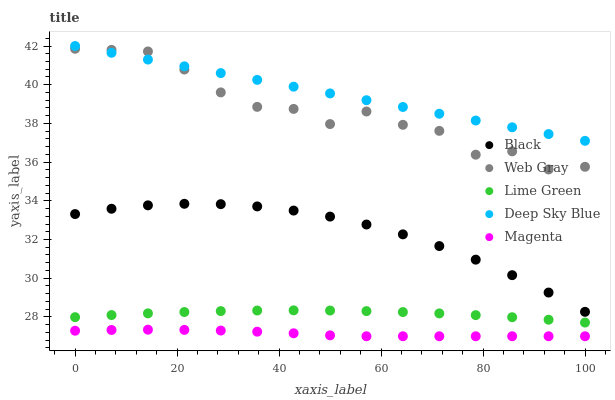Does Magenta have the minimum area under the curve?
Answer yes or no. Yes. Does Deep Sky Blue have the maximum area under the curve?
Answer yes or no. Yes. Does Web Gray have the minimum area under the curve?
Answer yes or no. No. Does Web Gray have the maximum area under the curve?
Answer yes or no. No. Is Deep Sky Blue the smoothest?
Answer yes or no. Yes. Is Web Gray the roughest?
Answer yes or no. Yes. Is Magenta the smoothest?
Answer yes or no. No. Is Magenta the roughest?
Answer yes or no. No. Does Magenta have the lowest value?
Answer yes or no. Yes. Does Web Gray have the lowest value?
Answer yes or no. No. Does Deep Sky Blue have the highest value?
Answer yes or no. Yes. Does Web Gray have the highest value?
Answer yes or no. No. Is Lime Green less than Black?
Answer yes or no. Yes. Is Lime Green greater than Magenta?
Answer yes or no. Yes. Does Deep Sky Blue intersect Web Gray?
Answer yes or no. Yes. Is Deep Sky Blue less than Web Gray?
Answer yes or no. No. Is Deep Sky Blue greater than Web Gray?
Answer yes or no. No. Does Lime Green intersect Black?
Answer yes or no. No. 